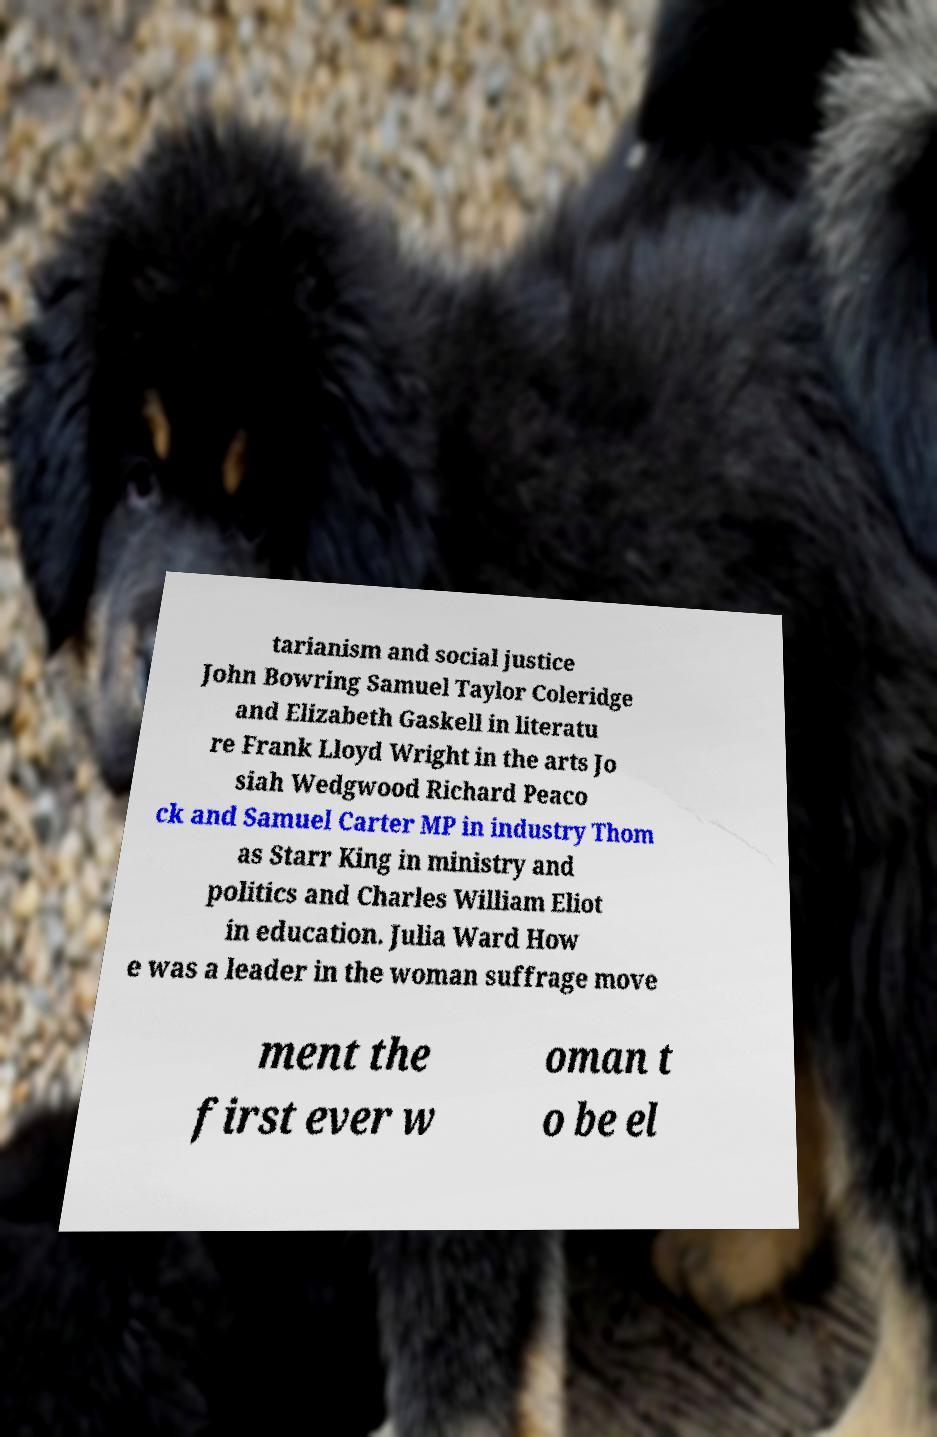What messages or text are displayed in this image? I need them in a readable, typed format. tarianism and social justice John Bowring Samuel Taylor Coleridge and Elizabeth Gaskell in literatu re Frank Lloyd Wright in the arts Jo siah Wedgwood Richard Peaco ck and Samuel Carter MP in industry Thom as Starr King in ministry and politics and Charles William Eliot in education. Julia Ward How e was a leader in the woman suffrage move ment the first ever w oman t o be el 